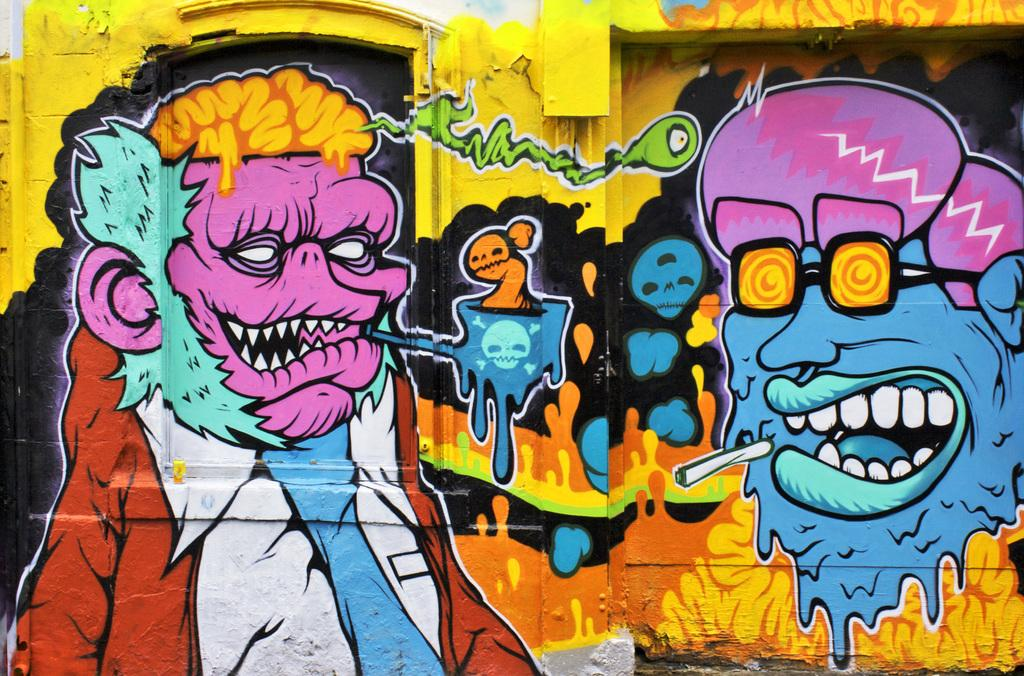What can be seen on the wall in the image? There is a paint on the wall in the image. What committee is responsible for the paint on the wall in the image? There is no committee mentioned or implied in the image, as it only shows a paint on the wall. 